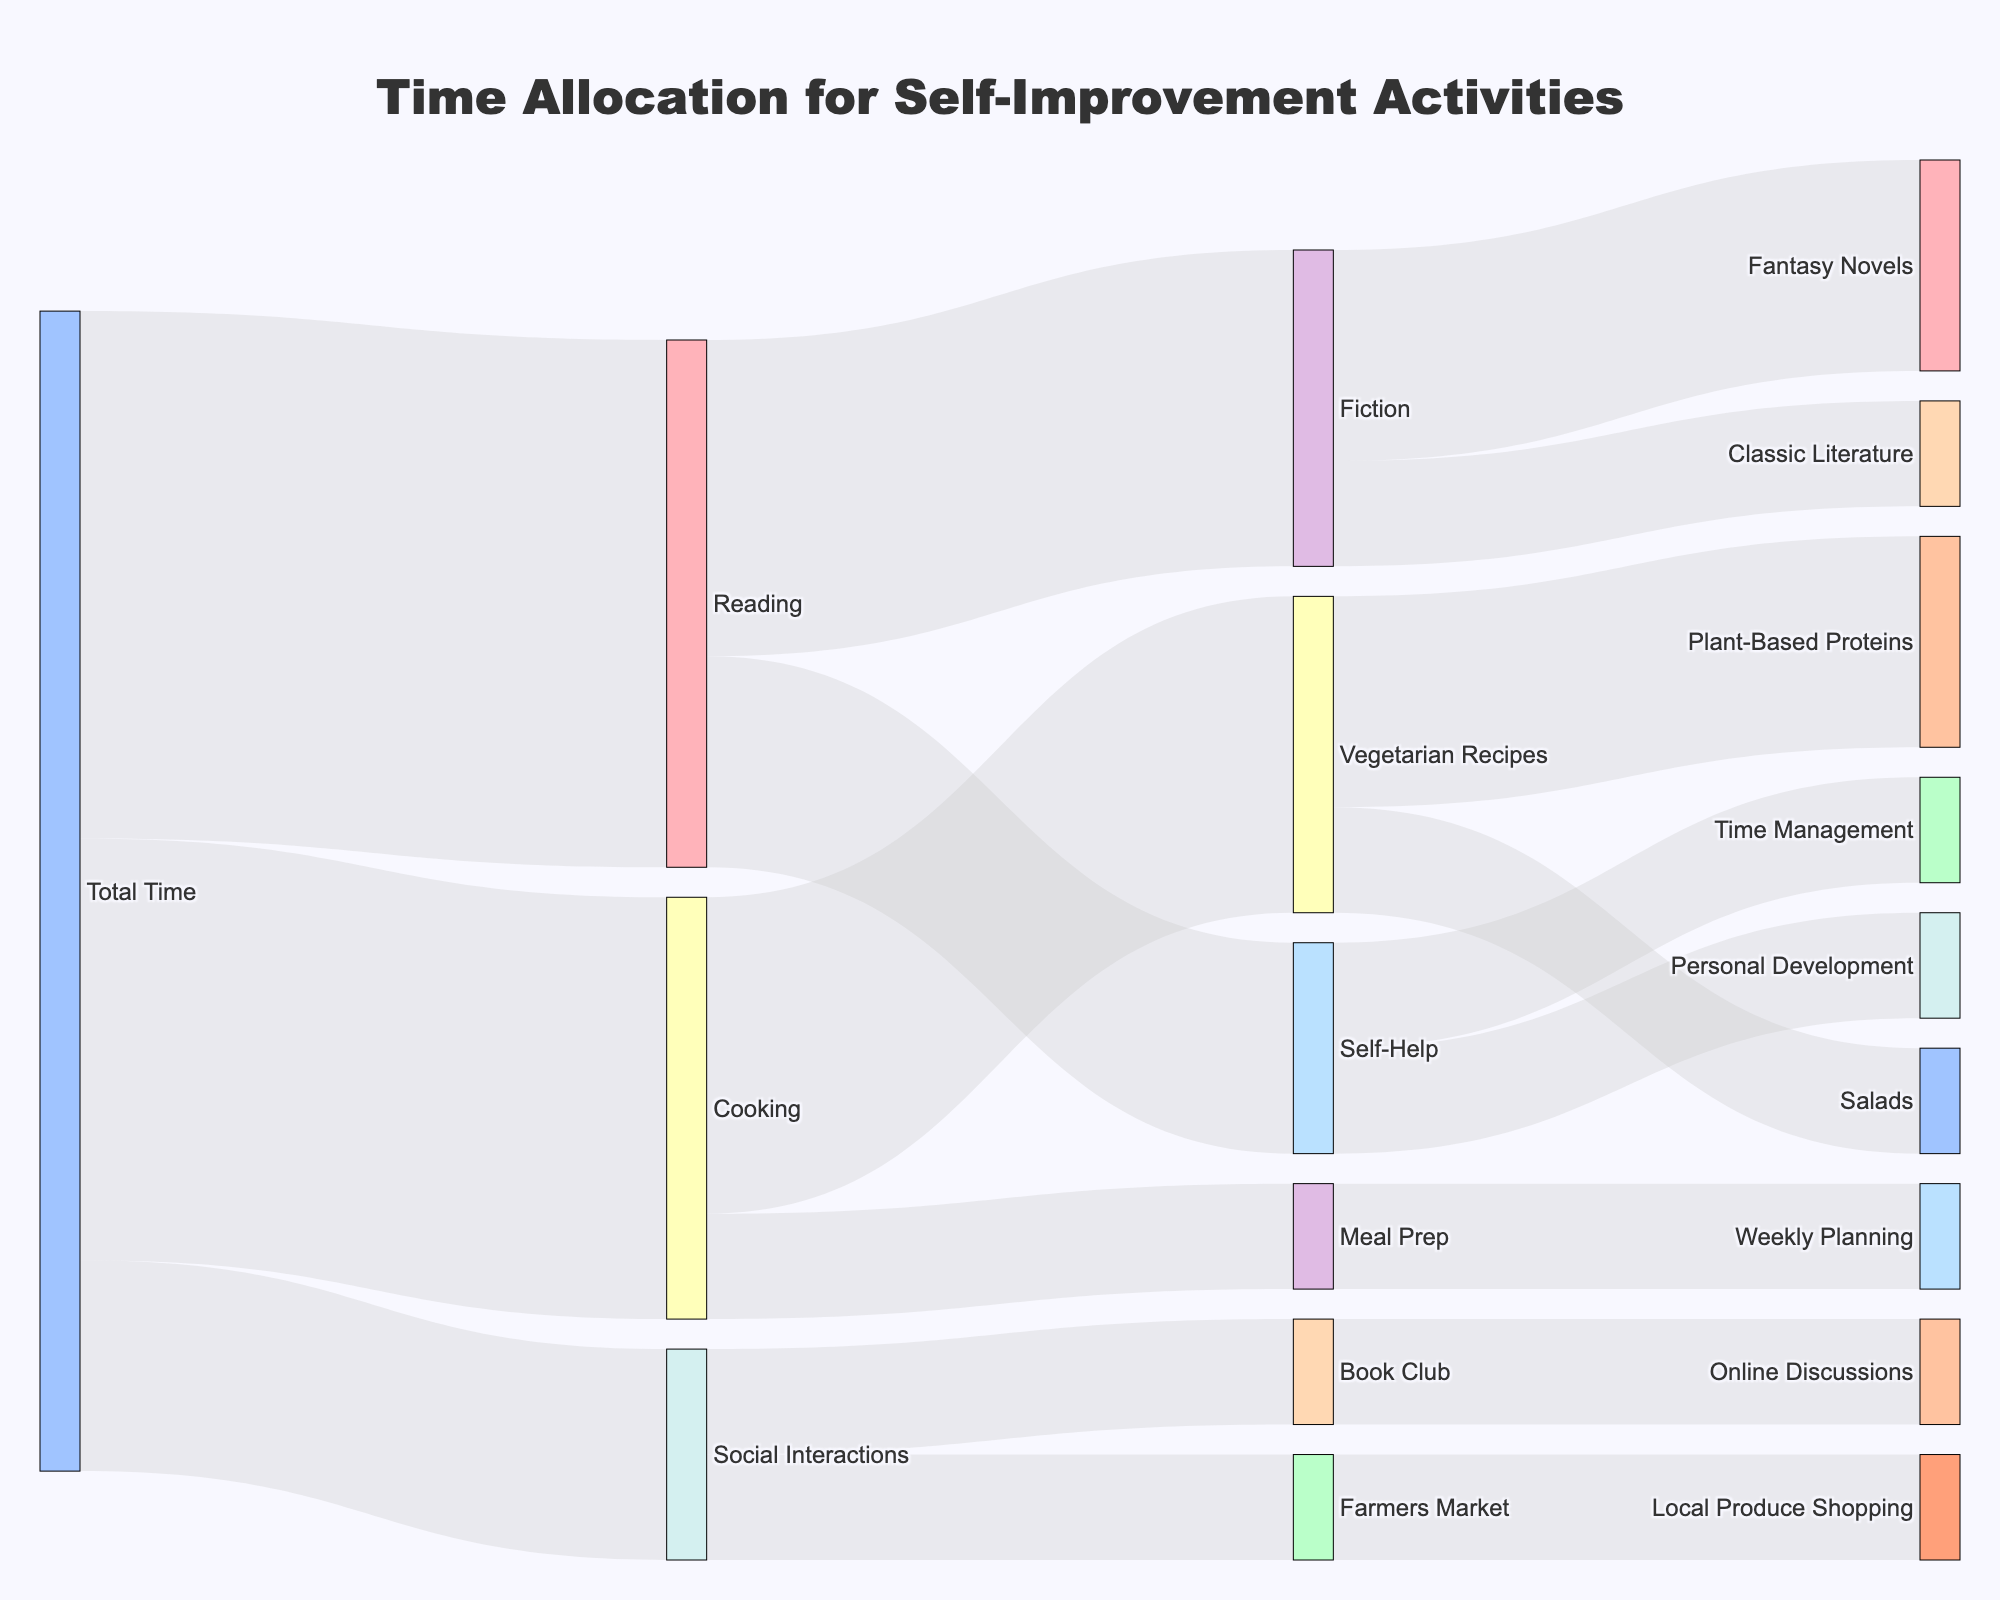What's the total time allocated to self-improvement activities? The total time allocation for self-improvement activities can be found by looking at the 'Total Time' node. The values for Reading, Cooking, and Social Interactions are 5, 4, and 2, respectively. Summing these values gives 5 + 4 + 2 = 11.
Answer: 11 How much time is spent on Fantasy Novels compared to Classic Literature? Follow the 'Fiction' node, which splits into 'Fantasy Novels' and 'Classic Literature'. Fantasy Novels has a value of 2, and Classic Literature has a value of 1. Thus, more time is spent on Fantasy Novels.
Answer: More time on Fantasy Novels What's the most time-consuming activity under Cooking? The 'Cooking' node splits into 'Vegetarian Recipes' and 'Meal Prep'. The values are 3 for Vegetarian Recipes and 1 for Meal Prep. Vegetarian Recipes is the most time-consuming.
Answer: Vegetarian Recipes How much time is devoted to Social Interactions activities in total? The 'Social Interactions' node splits into 'Book Club' and 'Farmers Market'. The values are 1 each for Book Club and Farmers Market. Summing these values gives 1 + 1 = 2.
Answer: 2 Which Reading sub-activity consumes the least time? The 'Reading' node splits into 'Fiction' and 'Self-Help'. Further, 'Fiction' splits into 'Fantasy Novels' and 'Classic Literature' and 'Self-Help' splits into 'Personal Development' and 'Time Management'. Classic Literature and 'Personal Development' and 'Time Management' all have values of 1. These three are the least time-consuming.
Answer: Classic Literature, Personal Development and Time Management Between Vegetarian Recipes and Book Club, which has higher time allocation? The 'Cooking' node splits into 'Vegetarian Recipes' (value 3) and the 'Social Interactions' node splits into 'Book Club' (value 1). Comparing these values, Vegetarian Recipes has a higher time allocation.
Answer: Vegetarian Recipes List all of the nodes connected to 'Reading'. Starting from the 'Reading' node, it splits into two sub-nodes: 'Fiction' and 'Self-Help'. 'Fiction' further splits into 'Fantasy Novels' and 'Classic Literature', while 'Self-Help' further splits into 'Personal Development' and 'Time Management'.
Answer: Fiction, Self-Help, Fantasy Novels, Classic Literature, Personal Development, Time Management Sum up the time allocated to all Cooking-related activities. The 'Cooking' node has two main sub-nodes: 'Vegetarian Recipes' and 'Meal Prep'. Each of these further splits into sub-nodes. The values are 3 for Vegetarian Recipes and 1 for Meal Prep. Summing these gives 3 + 1 = 4.
Answer: 4 Identify the smallest time allocation value and its corresponding activity. Looking at the Sankey diagram, the smallest values are 1, and these are for 'Meal Prep', 'Book Club', 'Farmers Market', 'Classic Literature', 'Personal Development', and 'Time Management'.
Answer: Meal Prep, Book Club, Farmers Market, Classic Literature, Personal Development, Time Management 